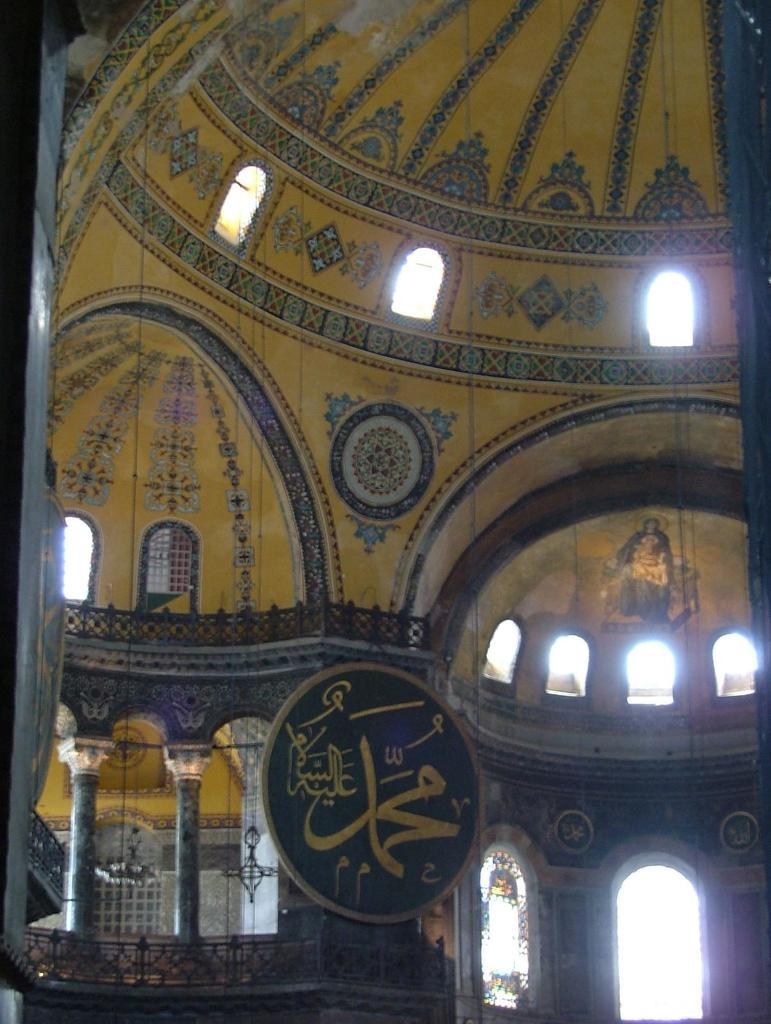What type of location is depicted in the image? The image shows the inside of a building. What architectural feature can be seen in the building? There are windows in the building. What object is visible in the image? There is a board visible in the image. What type of cow can be seen regretting its decision in the image? There is no cow present in the image, and therefore no such regret can be observed. 